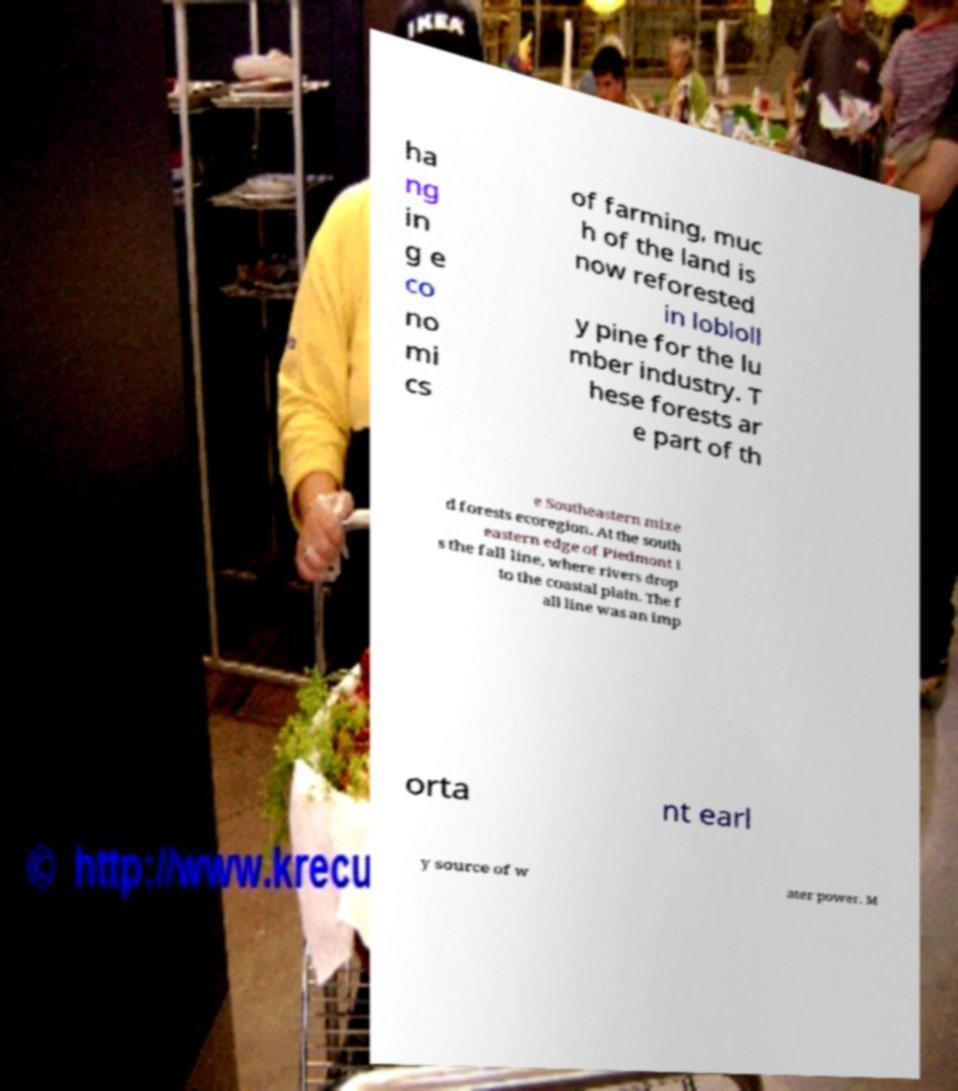For documentation purposes, I need the text within this image transcribed. Could you provide that? ha ng in g e co no mi cs of farming, muc h of the land is now reforested in lobloll y pine for the lu mber industry. T hese forests ar e part of th e Southeastern mixe d forests ecoregion. At the south eastern edge of Piedmont i s the fall line, where rivers drop to the coastal plain. The f all line was an imp orta nt earl y source of w ater power. M 